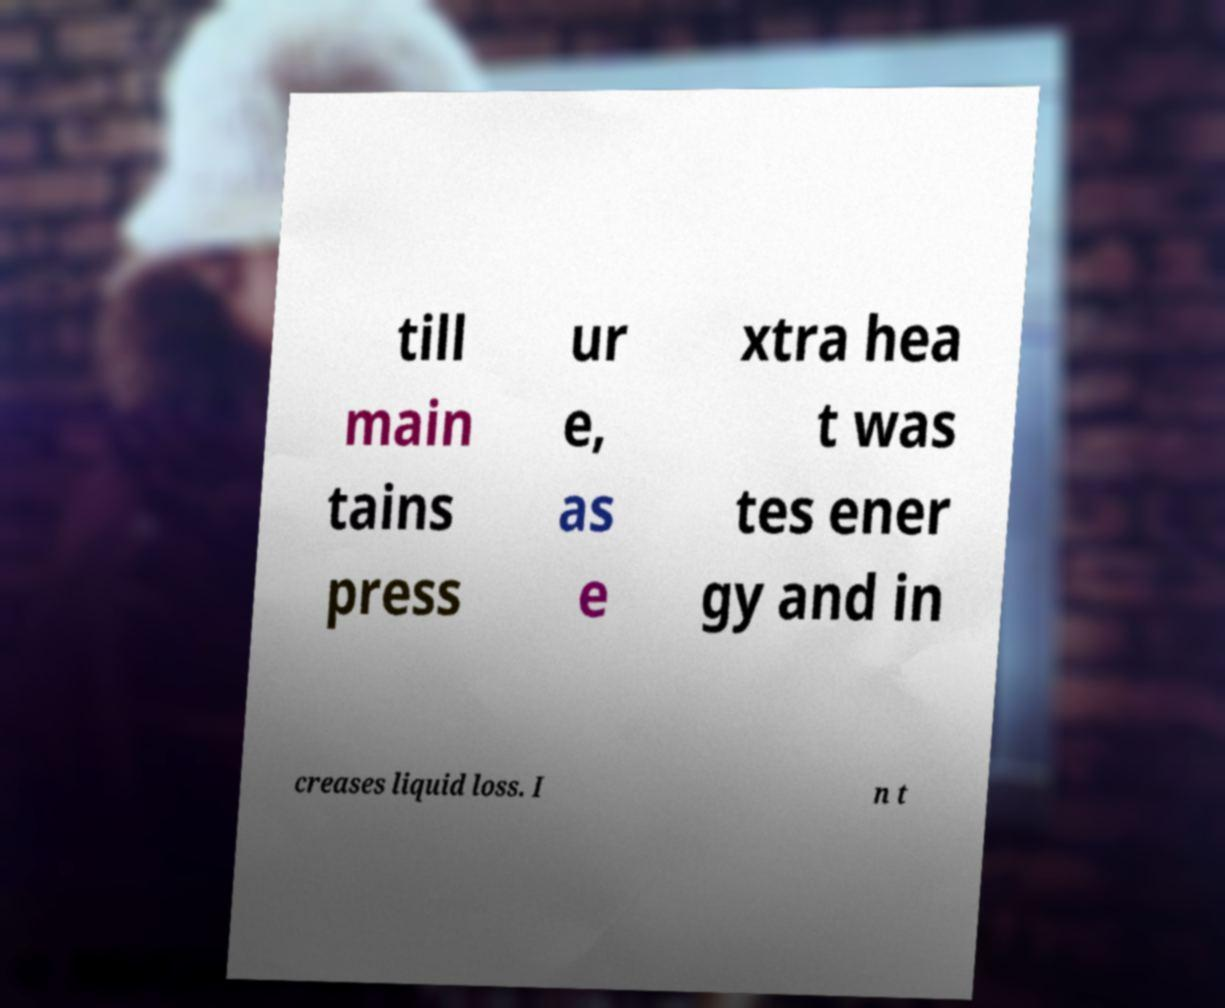For documentation purposes, I need the text within this image transcribed. Could you provide that? till main tains press ur e, as e xtra hea t was tes ener gy and in creases liquid loss. I n t 